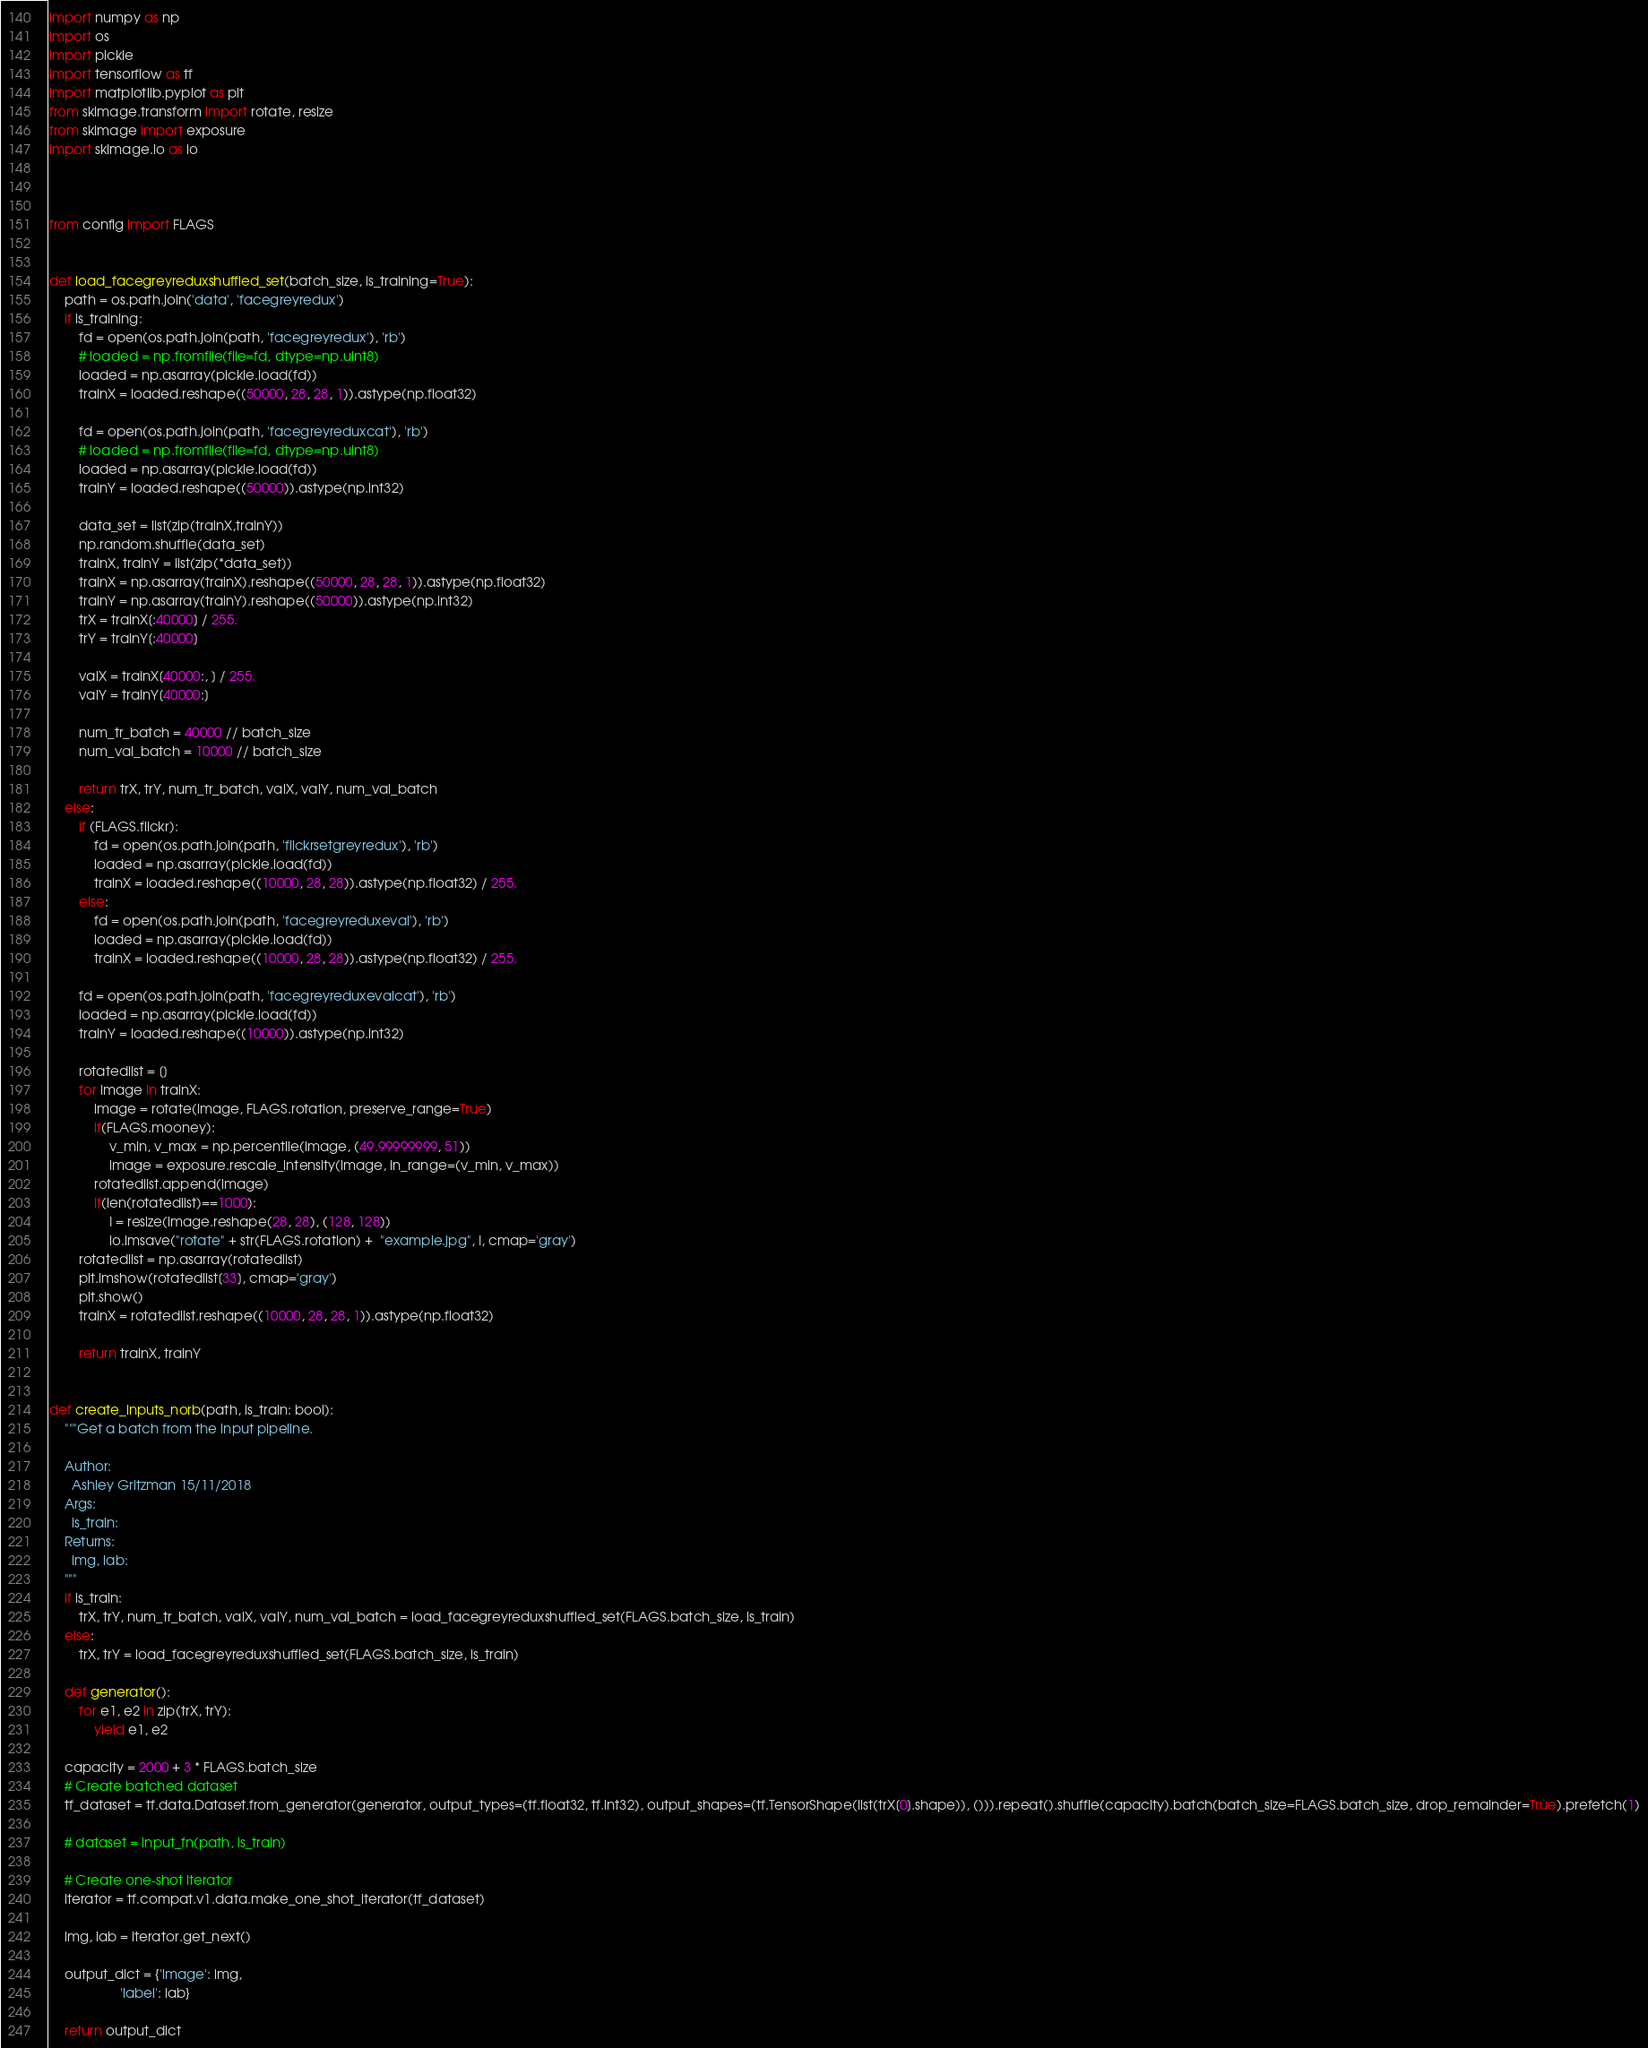<code> <loc_0><loc_0><loc_500><loc_500><_Python_>import numpy as np
import os
import pickle
import tensorflow as tf
import matplotlib.pyplot as plt
from skimage.transform import rotate, resize
from skimage import exposure
import skimage.io as io



from config import FLAGS


def load_facegreyreduxshuffled_set(batch_size, is_training=True):
    path = os.path.join('data', 'facegreyredux')
    if is_training:
        fd = open(os.path.join(path, 'facegreyredux'), 'rb')
        # loaded = np.fromfile(file=fd, dtype=np.uint8)
        loaded = np.asarray(pickle.load(fd))
        trainX = loaded.reshape((50000, 28, 28, 1)).astype(np.float32)

        fd = open(os.path.join(path, 'facegreyreduxcat'), 'rb')
        # loaded = np.fromfile(file=fd, dtype=np.uint8)
        loaded = np.asarray(pickle.load(fd))
        trainY = loaded.reshape((50000)).astype(np.int32)

        data_set = list(zip(trainX,trainY))
        np.random.shuffle(data_set)
        trainX, trainY = list(zip(*data_set))
        trainX = np.asarray(trainX).reshape((50000, 28, 28, 1)).astype(np.float32)
        trainY = np.asarray(trainY).reshape((50000)).astype(np.int32)
        trX = trainX[:40000] / 255.
        trY = trainY[:40000]

        valX = trainX[40000:, ] / 255.
        valY = trainY[40000:]

        num_tr_batch = 40000 // batch_size
        num_val_batch = 10000 // batch_size

        return trX, trY, num_tr_batch, valX, valY, num_val_batch
    else:
        if (FLAGS.flickr):
            fd = open(os.path.join(path, 'flickrsetgreyredux'), 'rb')
            loaded = np.asarray(pickle.load(fd))
            trainX = loaded.reshape((10000, 28, 28)).astype(np.float32) / 255.
        else:
            fd = open(os.path.join(path, 'facegreyreduxeval'), 'rb')
            loaded = np.asarray(pickle.load(fd))
            trainX = loaded.reshape((10000, 28, 28)).astype(np.float32) / 255.

        fd = open(os.path.join(path, 'facegreyreduxevalcat'), 'rb')
        loaded = np.asarray(pickle.load(fd))
        trainY = loaded.reshape((10000)).astype(np.int32)

        rotatedlist = []
        for image in trainX:
            image = rotate(image, FLAGS.rotation, preserve_range=True)
            if(FLAGS.mooney):
                v_min, v_max = np.percentile(image, (49.99999999, 51))
                image = exposure.rescale_intensity(image, in_range=(v_min, v_max))
            rotatedlist.append(image)
            if(len(rotatedlist)==1000):
                I = resize(image.reshape(28, 28), (128, 128))
                io.imsave("rotate" + str(FLAGS.rotation) +  "example.jpg", I, cmap='gray')
        rotatedlist = np.asarray(rotatedlist)
        plt.imshow(rotatedlist[33], cmap='gray')
        plt.show()
        trainX = rotatedlist.reshape((10000, 28, 28, 1)).astype(np.float32)

        return trainX, trainY


def create_inputs_norb(path, is_train: bool):
    """Get a batch from the input pipeline.

    Author:
      Ashley Gritzman 15/11/2018
    Args:
      is_train:
    Returns:
      img, lab:
    """
    if is_train:
        trX, trY, num_tr_batch, valX, valY, num_val_batch = load_facegreyreduxshuffled_set(FLAGS.batch_size, is_train)
    else:
        trX, trY = load_facegreyreduxshuffled_set(FLAGS.batch_size, is_train)

    def generator():
        for e1, e2 in zip(trX, trY):
            yield e1, e2

    capacity = 2000 + 3 * FLAGS.batch_size
    # Create batched dataset
    tf_dataset = tf.data.Dataset.from_generator(generator, output_types=(tf.float32, tf.int32), output_shapes=(tf.TensorShape(list(trX[0].shape)), ())).repeat().shuffle(capacity).batch(batch_size=FLAGS.batch_size, drop_remainder=True).prefetch(1)

    # dataset = input_fn(path, is_train)

    # Create one-shot iterator
    iterator = tf.compat.v1.data.make_one_shot_iterator(tf_dataset)

    img, lab = iterator.get_next()

    output_dict = {'image': img,
                   'label': lab}

    return output_dict
</code> 